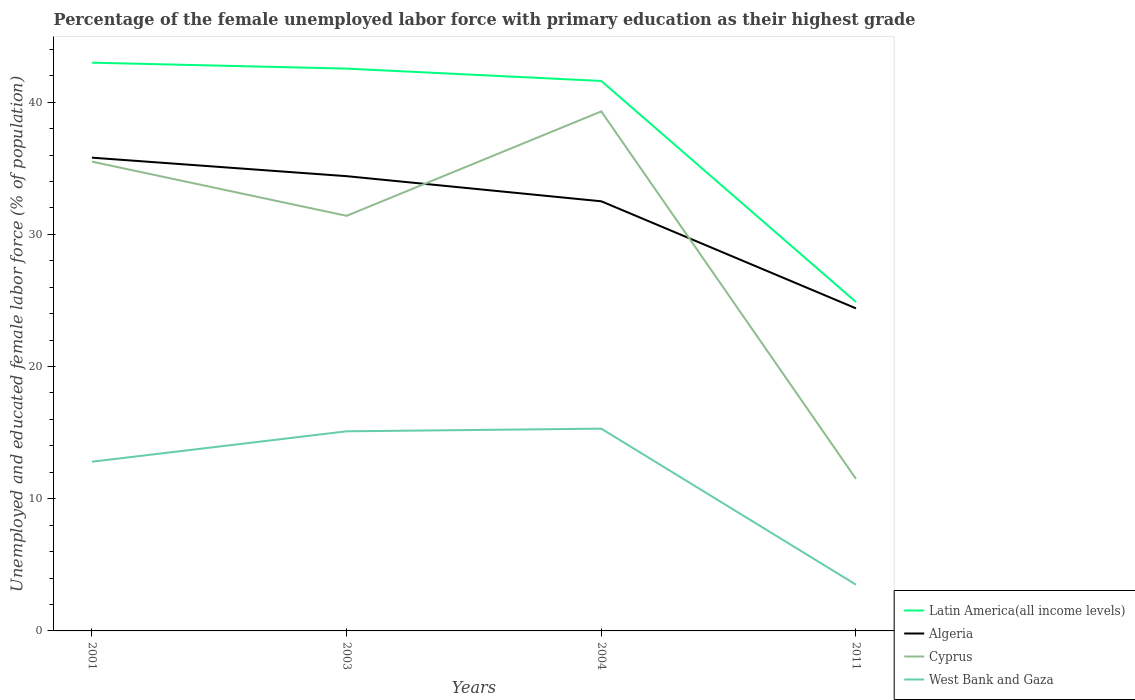Is the number of lines equal to the number of legend labels?
Provide a succinct answer. Yes. Across all years, what is the maximum percentage of the unemployed female labor force with primary education in Latin America(all income levels)?
Make the answer very short. 24.88. What is the total percentage of the unemployed female labor force with primary education in West Bank and Gaza in the graph?
Keep it short and to the point. 11.6. What is the difference between the highest and the second highest percentage of the unemployed female labor force with primary education in Cyprus?
Give a very brief answer. 27.8. Is the percentage of the unemployed female labor force with primary education in West Bank and Gaza strictly greater than the percentage of the unemployed female labor force with primary education in Latin America(all income levels) over the years?
Provide a short and direct response. Yes. Does the graph contain any zero values?
Your response must be concise. No. Does the graph contain grids?
Offer a very short reply. No. What is the title of the graph?
Give a very brief answer. Percentage of the female unemployed labor force with primary education as their highest grade. Does "European Union" appear as one of the legend labels in the graph?
Your answer should be very brief. No. What is the label or title of the X-axis?
Your answer should be very brief. Years. What is the label or title of the Y-axis?
Your answer should be compact. Unemployed and educated female labor force (% of population). What is the Unemployed and educated female labor force (% of population) in Latin America(all income levels) in 2001?
Your answer should be compact. 42.99. What is the Unemployed and educated female labor force (% of population) of Algeria in 2001?
Your answer should be compact. 35.8. What is the Unemployed and educated female labor force (% of population) of Cyprus in 2001?
Keep it short and to the point. 35.5. What is the Unemployed and educated female labor force (% of population) of West Bank and Gaza in 2001?
Provide a succinct answer. 12.8. What is the Unemployed and educated female labor force (% of population) in Latin America(all income levels) in 2003?
Keep it short and to the point. 42.54. What is the Unemployed and educated female labor force (% of population) in Algeria in 2003?
Offer a very short reply. 34.4. What is the Unemployed and educated female labor force (% of population) in Cyprus in 2003?
Your response must be concise. 31.4. What is the Unemployed and educated female labor force (% of population) in West Bank and Gaza in 2003?
Offer a terse response. 15.1. What is the Unemployed and educated female labor force (% of population) in Latin America(all income levels) in 2004?
Offer a very short reply. 41.6. What is the Unemployed and educated female labor force (% of population) in Algeria in 2004?
Provide a succinct answer. 32.5. What is the Unemployed and educated female labor force (% of population) in Cyprus in 2004?
Your answer should be very brief. 39.3. What is the Unemployed and educated female labor force (% of population) in West Bank and Gaza in 2004?
Ensure brevity in your answer.  15.3. What is the Unemployed and educated female labor force (% of population) of Latin America(all income levels) in 2011?
Give a very brief answer. 24.88. What is the Unemployed and educated female labor force (% of population) in Algeria in 2011?
Ensure brevity in your answer.  24.4. What is the Unemployed and educated female labor force (% of population) of Cyprus in 2011?
Make the answer very short. 11.5. Across all years, what is the maximum Unemployed and educated female labor force (% of population) in Latin America(all income levels)?
Ensure brevity in your answer.  42.99. Across all years, what is the maximum Unemployed and educated female labor force (% of population) in Algeria?
Keep it short and to the point. 35.8. Across all years, what is the maximum Unemployed and educated female labor force (% of population) of Cyprus?
Give a very brief answer. 39.3. Across all years, what is the maximum Unemployed and educated female labor force (% of population) in West Bank and Gaza?
Offer a very short reply. 15.3. Across all years, what is the minimum Unemployed and educated female labor force (% of population) in Latin America(all income levels)?
Offer a terse response. 24.88. Across all years, what is the minimum Unemployed and educated female labor force (% of population) in Algeria?
Ensure brevity in your answer.  24.4. Across all years, what is the minimum Unemployed and educated female labor force (% of population) in Cyprus?
Give a very brief answer. 11.5. Across all years, what is the minimum Unemployed and educated female labor force (% of population) in West Bank and Gaza?
Keep it short and to the point. 3.5. What is the total Unemployed and educated female labor force (% of population) in Latin America(all income levels) in the graph?
Ensure brevity in your answer.  152.01. What is the total Unemployed and educated female labor force (% of population) in Algeria in the graph?
Offer a very short reply. 127.1. What is the total Unemployed and educated female labor force (% of population) in Cyprus in the graph?
Offer a terse response. 117.7. What is the total Unemployed and educated female labor force (% of population) in West Bank and Gaza in the graph?
Ensure brevity in your answer.  46.7. What is the difference between the Unemployed and educated female labor force (% of population) of Latin America(all income levels) in 2001 and that in 2003?
Provide a succinct answer. 0.45. What is the difference between the Unemployed and educated female labor force (% of population) in Cyprus in 2001 and that in 2003?
Ensure brevity in your answer.  4.1. What is the difference between the Unemployed and educated female labor force (% of population) of Latin America(all income levels) in 2001 and that in 2004?
Your response must be concise. 1.38. What is the difference between the Unemployed and educated female labor force (% of population) of Algeria in 2001 and that in 2004?
Your answer should be very brief. 3.3. What is the difference between the Unemployed and educated female labor force (% of population) of Latin America(all income levels) in 2001 and that in 2011?
Offer a terse response. 18.1. What is the difference between the Unemployed and educated female labor force (% of population) of Algeria in 2001 and that in 2011?
Provide a succinct answer. 11.4. What is the difference between the Unemployed and educated female labor force (% of population) in Cyprus in 2001 and that in 2011?
Your response must be concise. 24. What is the difference between the Unemployed and educated female labor force (% of population) of West Bank and Gaza in 2001 and that in 2011?
Ensure brevity in your answer.  9.3. What is the difference between the Unemployed and educated female labor force (% of population) in Latin America(all income levels) in 2003 and that in 2004?
Give a very brief answer. 0.93. What is the difference between the Unemployed and educated female labor force (% of population) of Cyprus in 2003 and that in 2004?
Your answer should be very brief. -7.9. What is the difference between the Unemployed and educated female labor force (% of population) of Latin America(all income levels) in 2003 and that in 2011?
Offer a terse response. 17.66. What is the difference between the Unemployed and educated female labor force (% of population) in Algeria in 2003 and that in 2011?
Offer a terse response. 10. What is the difference between the Unemployed and educated female labor force (% of population) of Cyprus in 2003 and that in 2011?
Offer a very short reply. 19.9. What is the difference between the Unemployed and educated female labor force (% of population) of Latin America(all income levels) in 2004 and that in 2011?
Give a very brief answer. 16.72. What is the difference between the Unemployed and educated female labor force (% of population) of Algeria in 2004 and that in 2011?
Your answer should be very brief. 8.1. What is the difference between the Unemployed and educated female labor force (% of population) in Cyprus in 2004 and that in 2011?
Make the answer very short. 27.8. What is the difference between the Unemployed and educated female labor force (% of population) of Latin America(all income levels) in 2001 and the Unemployed and educated female labor force (% of population) of Algeria in 2003?
Make the answer very short. 8.59. What is the difference between the Unemployed and educated female labor force (% of population) of Latin America(all income levels) in 2001 and the Unemployed and educated female labor force (% of population) of Cyprus in 2003?
Provide a succinct answer. 11.59. What is the difference between the Unemployed and educated female labor force (% of population) of Latin America(all income levels) in 2001 and the Unemployed and educated female labor force (% of population) of West Bank and Gaza in 2003?
Keep it short and to the point. 27.89. What is the difference between the Unemployed and educated female labor force (% of population) in Algeria in 2001 and the Unemployed and educated female labor force (% of population) in West Bank and Gaza in 2003?
Your answer should be very brief. 20.7. What is the difference between the Unemployed and educated female labor force (% of population) in Cyprus in 2001 and the Unemployed and educated female labor force (% of population) in West Bank and Gaza in 2003?
Provide a short and direct response. 20.4. What is the difference between the Unemployed and educated female labor force (% of population) of Latin America(all income levels) in 2001 and the Unemployed and educated female labor force (% of population) of Algeria in 2004?
Ensure brevity in your answer.  10.49. What is the difference between the Unemployed and educated female labor force (% of population) of Latin America(all income levels) in 2001 and the Unemployed and educated female labor force (% of population) of Cyprus in 2004?
Ensure brevity in your answer.  3.69. What is the difference between the Unemployed and educated female labor force (% of population) in Latin America(all income levels) in 2001 and the Unemployed and educated female labor force (% of population) in West Bank and Gaza in 2004?
Provide a succinct answer. 27.69. What is the difference between the Unemployed and educated female labor force (% of population) in Algeria in 2001 and the Unemployed and educated female labor force (% of population) in Cyprus in 2004?
Give a very brief answer. -3.5. What is the difference between the Unemployed and educated female labor force (% of population) of Algeria in 2001 and the Unemployed and educated female labor force (% of population) of West Bank and Gaza in 2004?
Offer a very short reply. 20.5. What is the difference between the Unemployed and educated female labor force (% of population) of Cyprus in 2001 and the Unemployed and educated female labor force (% of population) of West Bank and Gaza in 2004?
Your answer should be very brief. 20.2. What is the difference between the Unemployed and educated female labor force (% of population) in Latin America(all income levels) in 2001 and the Unemployed and educated female labor force (% of population) in Algeria in 2011?
Make the answer very short. 18.59. What is the difference between the Unemployed and educated female labor force (% of population) in Latin America(all income levels) in 2001 and the Unemployed and educated female labor force (% of population) in Cyprus in 2011?
Give a very brief answer. 31.49. What is the difference between the Unemployed and educated female labor force (% of population) in Latin America(all income levels) in 2001 and the Unemployed and educated female labor force (% of population) in West Bank and Gaza in 2011?
Provide a short and direct response. 39.49. What is the difference between the Unemployed and educated female labor force (% of population) in Algeria in 2001 and the Unemployed and educated female labor force (% of population) in Cyprus in 2011?
Offer a terse response. 24.3. What is the difference between the Unemployed and educated female labor force (% of population) of Algeria in 2001 and the Unemployed and educated female labor force (% of population) of West Bank and Gaza in 2011?
Ensure brevity in your answer.  32.3. What is the difference between the Unemployed and educated female labor force (% of population) of Cyprus in 2001 and the Unemployed and educated female labor force (% of population) of West Bank and Gaza in 2011?
Give a very brief answer. 32. What is the difference between the Unemployed and educated female labor force (% of population) in Latin America(all income levels) in 2003 and the Unemployed and educated female labor force (% of population) in Algeria in 2004?
Your answer should be very brief. 10.04. What is the difference between the Unemployed and educated female labor force (% of population) of Latin America(all income levels) in 2003 and the Unemployed and educated female labor force (% of population) of Cyprus in 2004?
Give a very brief answer. 3.24. What is the difference between the Unemployed and educated female labor force (% of population) in Latin America(all income levels) in 2003 and the Unemployed and educated female labor force (% of population) in West Bank and Gaza in 2004?
Ensure brevity in your answer.  27.24. What is the difference between the Unemployed and educated female labor force (% of population) of Algeria in 2003 and the Unemployed and educated female labor force (% of population) of Cyprus in 2004?
Provide a short and direct response. -4.9. What is the difference between the Unemployed and educated female labor force (% of population) in Latin America(all income levels) in 2003 and the Unemployed and educated female labor force (% of population) in Algeria in 2011?
Your response must be concise. 18.14. What is the difference between the Unemployed and educated female labor force (% of population) in Latin America(all income levels) in 2003 and the Unemployed and educated female labor force (% of population) in Cyprus in 2011?
Your answer should be very brief. 31.04. What is the difference between the Unemployed and educated female labor force (% of population) of Latin America(all income levels) in 2003 and the Unemployed and educated female labor force (% of population) of West Bank and Gaza in 2011?
Offer a very short reply. 39.04. What is the difference between the Unemployed and educated female labor force (% of population) in Algeria in 2003 and the Unemployed and educated female labor force (% of population) in Cyprus in 2011?
Your answer should be very brief. 22.9. What is the difference between the Unemployed and educated female labor force (% of population) of Algeria in 2003 and the Unemployed and educated female labor force (% of population) of West Bank and Gaza in 2011?
Ensure brevity in your answer.  30.9. What is the difference between the Unemployed and educated female labor force (% of population) in Cyprus in 2003 and the Unemployed and educated female labor force (% of population) in West Bank and Gaza in 2011?
Provide a short and direct response. 27.9. What is the difference between the Unemployed and educated female labor force (% of population) of Latin America(all income levels) in 2004 and the Unemployed and educated female labor force (% of population) of Algeria in 2011?
Offer a very short reply. 17.2. What is the difference between the Unemployed and educated female labor force (% of population) of Latin America(all income levels) in 2004 and the Unemployed and educated female labor force (% of population) of Cyprus in 2011?
Keep it short and to the point. 30.1. What is the difference between the Unemployed and educated female labor force (% of population) of Latin America(all income levels) in 2004 and the Unemployed and educated female labor force (% of population) of West Bank and Gaza in 2011?
Your response must be concise. 38.1. What is the difference between the Unemployed and educated female labor force (% of population) of Algeria in 2004 and the Unemployed and educated female labor force (% of population) of West Bank and Gaza in 2011?
Ensure brevity in your answer.  29. What is the difference between the Unemployed and educated female labor force (% of population) of Cyprus in 2004 and the Unemployed and educated female labor force (% of population) of West Bank and Gaza in 2011?
Ensure brevity in your answer.  35.8. What is the average Unemployed and educated female labor force (% of population) of Latin America(all income levels) per year?
Provide a short and direct response. 38. What is the average Unemployed and educated female labor force (% of population) in Algeria per year?
Provide a succinct answer. 31.77. What is the average Unemployed and educated female labor force (% of population) in Cyprus per year?
Offer a terse response. 29.43. What is the average Unemployed and educated female labor force (% of population) in West Bank and Gaza per year?
Your answer should be very brief. 11.68. In the year 2001, what is the difference between the Unemployed and educated female labor force (% of population) in Latin America(all income levels) and Unemployed and educated female labor force (% of population) in Algeria?
Your answer should be very brief. 7.19. In the year 2001, what is the difference between the Unemployed and educated female labor force (% of population) of Latin America(all income levels) and Unemployed and educated female labor force (% of population) of Cyprus?
Provide a short and direct response. 7.49. In the year 2001, what is the difference between the Unemployed and educated female labor force (% of population) of Latin America(all income levels) and Unemployed and educated female labor force (% of population) of West Bank and Gaza?
Offer a terse response. 30.19. In the year 2001, what is the difference between the Unemployed and educated female labor force (% of population) of Algeria and Unemployed and educated female labor force (% of population) of Cyprus?
Make the answer very short. 0.3. In the year 2001, what is the difference between the Unemployed and educated female labor force (% of population) in Cyprus and Unemployed and educated female labor force (% of population) in West Bank and Gaza?
Offer a very short reply. 22.7. In the year 2003, what is the difference between the Unemployed and educated female labor force (% of population) in Latin America(all income levels) and Unemployed and educated female labor force (% of population) in Algeria?
Keep it short and to the point. 8.14. In the year 2003, what is the difference between the Unemployed and educated female labor force (% of population) of Latin America(all income levels) and Unemployed and educated female labor force (% of population) of Cyprus?
Give a very brief answer. 11.14. In the year 2003, what is the difference between the Unemployed and educated female labor force (% of population) in Latin America(all income levels) and Unemployed and educated female labor force (% of population) in West Bank and Gaza?
Your response must be concise. 27.44. In the year 2003, what is the difference between the Unemployed and educated female labor force (% of population) of Algeria and Unemployed and educated female labor force (% of population) of Cyprus?
Your response must be concise. 3. In the year 2003, what is the difference between the Unemployed and educated female labor force (% of population) of Algeria and Unemployed and educated female labor force (% of population) of West Bank and Gaza?
Keep it short and to the point. 19.3. In the year 2003, what is the difference between the Unemployed and educated female labor force (% of population) in Cyprus and Unemployed and educated female labor force (% of population) in West Bank and Gaza?
Provide a short and direct response. 16.3. In the year 2004, what is the difference between the Unemployed and educated female labor force (% of population) in Latin America(all income levels) and Unemployed and educated female labor force (% of population) in Algeria?
Your answer should be compact. 9.1. In the year 2004, what is the difference between the Unemployed and educated female labor force (% of population) of Latin America(all income levels) and Unemployed and educated female labor force (% of population) of Cyprus?
Your answer should be compact. 2.3. In the year 2004, what is the difference between the Unemployed and educated female labor force (% of population) in Latin America(all income levels) and Unemployed and educated female labor force (% of population) in West Bank and Gaza?
Your answer should be very brief. 26.3. In the year 2004, what is the difference between the Unemployed and educated female labor force (% of population) of Algeria and Unemployed and educated female labor force (% of population) of Cyprus?
Your response must be concise. -6.8. In the year 2011, what is the difference between the Unemployed and educated female labor force (% of population) of Latin America(all income levels) and Unemployed and educated female labor force (% of population) of Algeria?
Your answer should be very brief. 0.48. In the year 2011, what is the difference between the Unemployed and educated female labor force (% of population) of Latin America(all income levels) and Unemployed and educated female labor force (% of population) of Cyprus?
Your response must be concise. 13.38. In the year 2011, what is the difference between the Unemployed and educated female labor force (% of population) of Latin America(all income levels) and Unemployed and educated female labor force (% of population) of West Bank and Gaza?
Make the answer very short. 21.38. In the year 2011, what is the difference between the Unemployed and educated female labor force (% of population) in Algeria and Unemployed and educated female labor force (% of population) in West Bank and Gaza?
Give a very brief answer. 20.9. What is the ratio of the Unemployed and educated female labor force (% of population) in Latin America(all income levels) in 2001 to that in 2003?
Your answer should be very brief. 1.01. What is the ratio of the Unemployed and educated female labor force (% of population) of Algeria in 2001 to that in 2003?
Your answer should be compact. 1.04. What is the ratio of the Unemployed and educated female labor force (% of population) in Cyprus in 2001 to that in 2003?
Make the answer very short. 1.13. What is the ratio of the Unemployed and educated female labor force (% of population) in West Bank and Gaza in 2001 to that in 2003?
Your answer should be very brief. 0.85. What is the ratio of the Unemployed and educated female labor force (% of population) in Latin America(all income levels) in 2001 to that in 2004?
Offer a very short reply. 1.03. What is the ratio of the Unemployed and educated female labor force (% of population) in Algeria in 2001 to that in 2004?
Ensure brevity in your answer.  1.1. What is the ratio of the Unemployed and educated female labor force (% of population) in Cyprus in 2001 to that in 2004?
Provide a short and direct response. 0.9. What is the ratio of the Unemployed and educated female labor force (% of population) in West Bank and Gaza in 2001 to that in 2004?
Make the answer very short. 0.84. What is the ratio of the Unemployed and educated female labor force (% of population) of Latin America(all income levels) in 2001 to that in 2011?
Your response must be concise. 1.73. What is the ratio of the Unemployed and educated female labor force (% of population) in Algeria in 2001 to that in 2011?
Offer a terse response. 1.47. What is the ratio of the Unemployed and educated female labor force (% of population) in Cyprus in 2001 to that in 2011?
Give a very brief answer. 3.09. What is the ratio of the Unemployed and educated female labor force (% of population) of West Bank and Gaza in 2001 to that in 2011?
Provide a succinct answer. 3.66. What is the ratio of the Unemployed and educated female labor force (% of population) of Latin America(all income levels) in 2003 to that in 2004?
Keep it short and to the point. 1.02. What is the ratio of the Unemployed and educated female labor force (% of population) in Algeria in 2003 to that in 2004?
Provide a short and direct response. 1.06. What is the ratio of the Unemployed and educated female labor force (% of population) of Cyprus in 2003 to that in 2004?
Offer a terse response. 0.8. What is the ratio of the Unemployed and educated female labor force (% of population) of West Bank and Gaza in 2003 to that in 2004?
Your answer should be compact. 0.99. What is the ratio of the Unemployed and educated female labor force (% of population) in Latin America(all income levels) in 2003 to that in 2011?
Ensure brevity in your answer.  1.71. What is the ratio of the Unemployed and educated female labor force (% of population) of Algeria in 2003 to that in 2011?
Offer a terse response. 1.41. What is the ratio of the Unemployed and educated female labor force (% of population) in Cyprus in 2003 to that in 2011?
Provide a short and direct response. 2.73. What is the ratio of the Unemployed and educated female labor force (% of population) in West Bank and Gaza in 2003 to that in 2011?
Offer a terse response. 4.31. What is the ratio of the Unemployed and educated female labor force (% of population) in Latin America(all income levels) in 2004 to that in 2011?
Your answer should be very brief. 1.67. What is the ratio of the Unemployed and educated female labor force (% of population) of Algeria in 2004 to that in 2011?
Your response must be concise. 1.33. What is the ratio of the Unemployed and educated female labor force (% of population) of Cyprus in 2004 to that in 2011?
Your response must be concise. 3.42. What is the ratio of the Unemployed and educated female labor force (% of population) of West Bank and Gaza in 2004 to that in 2011?
Make the answer very short. 4.37. What is the difference between the highest and the second highest Unemployed and educated female labor force (% of population) in Latin America(all income levels)?
Provide a short and direct response. 0.45. What is the difference between the highest and the second highest Unemployed and educated female labor force (% of population) of Algeria?
Keep it short and to the point. 1.4. What is the difference between the highest and the second highest Unemployed and educated female labor force (% of population) of West Bank and Gaza?
Provide a succinct answer. 0.2. What is the difference between the highest and the lowest Unemployed and educated female labor force (% of population) of Latin America(all income levels)?
Ensure brevity in your answer.  18.1. What is the difference between the highest and the lowest Unemployed and educated female labor force (% of population) in Algeria?
Make the answer very short. 11.4. What is the difference between the highest and the lowest Unemployed and educated female labor force (% of population) of Cyprus?
Provide a succinct answer. 27.8. What is the difference between the highest and the lowest Unemployed and educated female labor force (% of population) of West Bank and Gaza?
Keep it short and to the point. 11.8. 